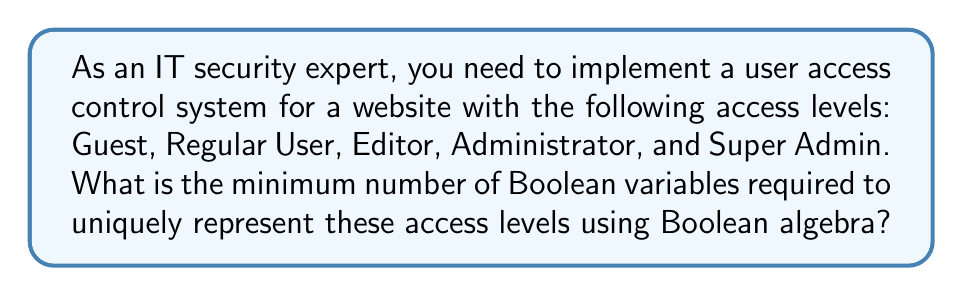Solve this math problem. To solve this problem, we need to follow these steps:

1. Count the number of distinct access levels:
   Guest, Regular User, Editor, Administrator, Super Admin
   Total: 5 distinct access levels

2. Calculate the minimum number of bits needed to represent these levels:
   We need to find $n$ such that $2^n \geq 5$

3. Let's calculate:
   $2^1 = 2$ (not enough)
   $2^2 = 4$ (not enough)
   $2^3 = 8$ (sufficient)

4. Therefore, we need 3 bits to represent 5 distinct access levels.

5. In Boolean algebra, each bit corresponds to a Boolean variable. So, we need 3 Boolean variables.

6. We can represent the access levels as follows:
   $000$: Guest
   $001$: Regular User
   $010$: Editor
   $011$: Administrator
   $100$: Super Admin

   (The remaining combinations $101$, $110$, and $111$ are unused)

Thus, the minimum number of Boolean variables needed is 3.
Answer: 3 